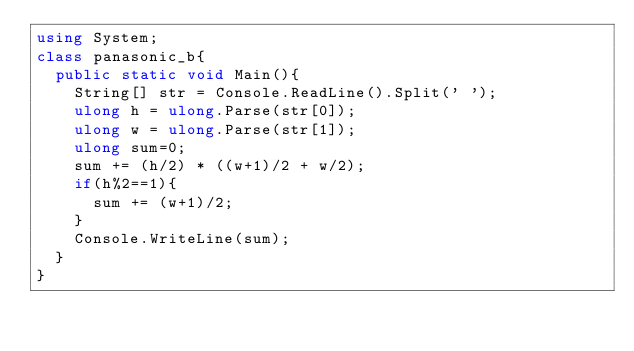<code> <loc_0><loc_0><loc_500><loc_500><_C#_>using System;
class panasonic_b{
  public static void Main(){
    String[] str = Console.ReadLine().Split(' ');
    ulong h = ulong.Parse(str[0]);
    ulong w = ulong.Parse(str[1]);
    ulong sum=0;
    sum += (h/2) * ((w+1)/2 + w/2);
    if(h%2==1){
      sum += (w+1)/2;
    }
    Console.WriteLine(sum);
  }
}
</code> 